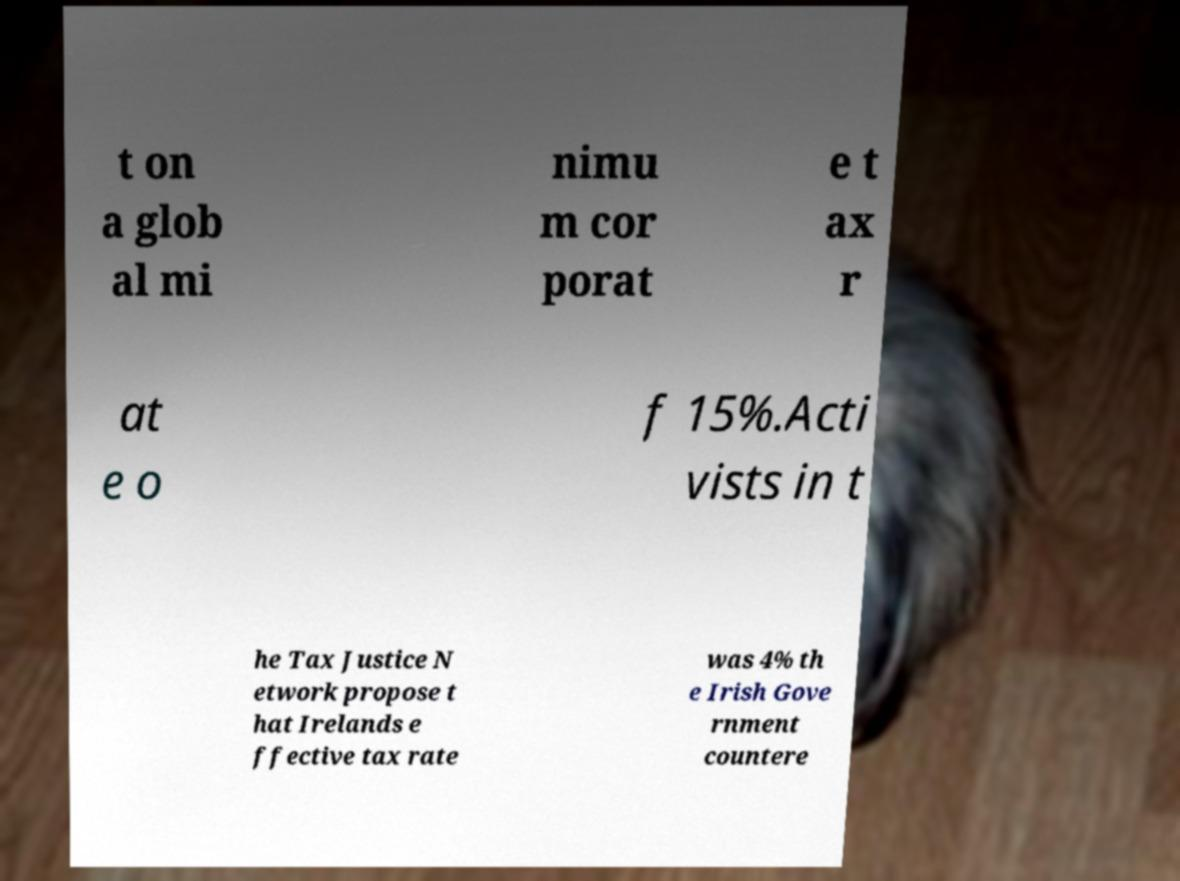Can you accurately transcribe the text from the provided image for me? t on a glob al mi nimu m cor porat e t ax r at e o f 15%.Acti vists in t he Tax Justice N etwork propose t hat Irelands e ffective tax rate was 4% th e Irish Gove rnment countere 